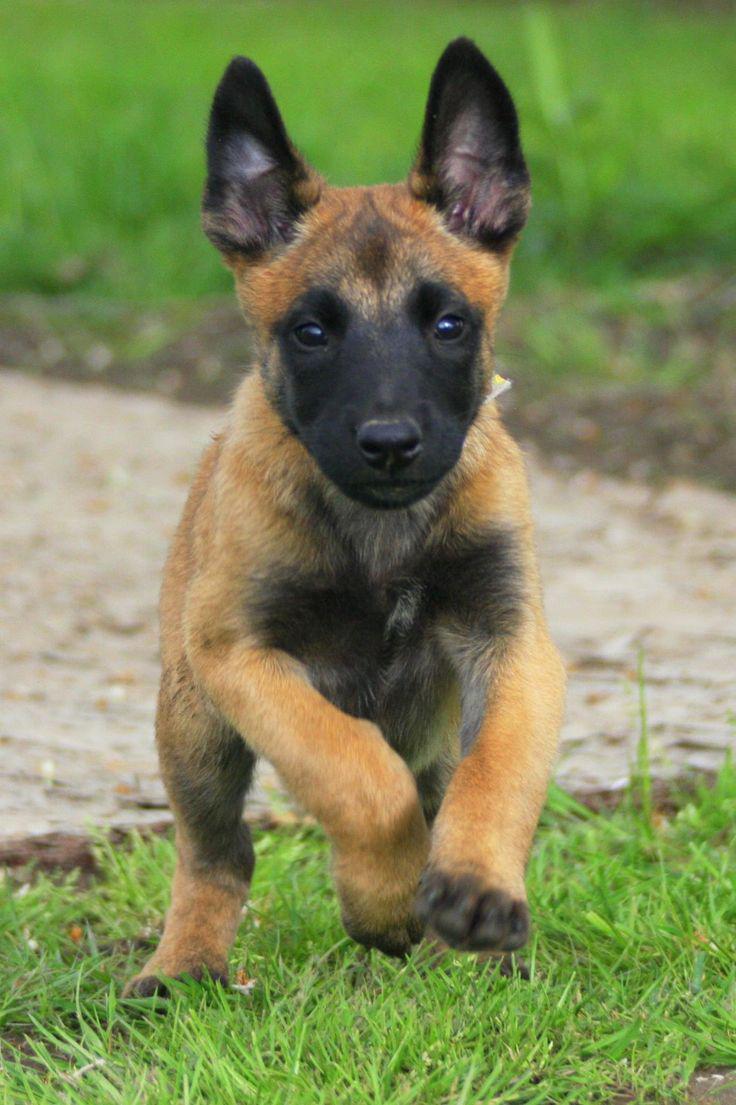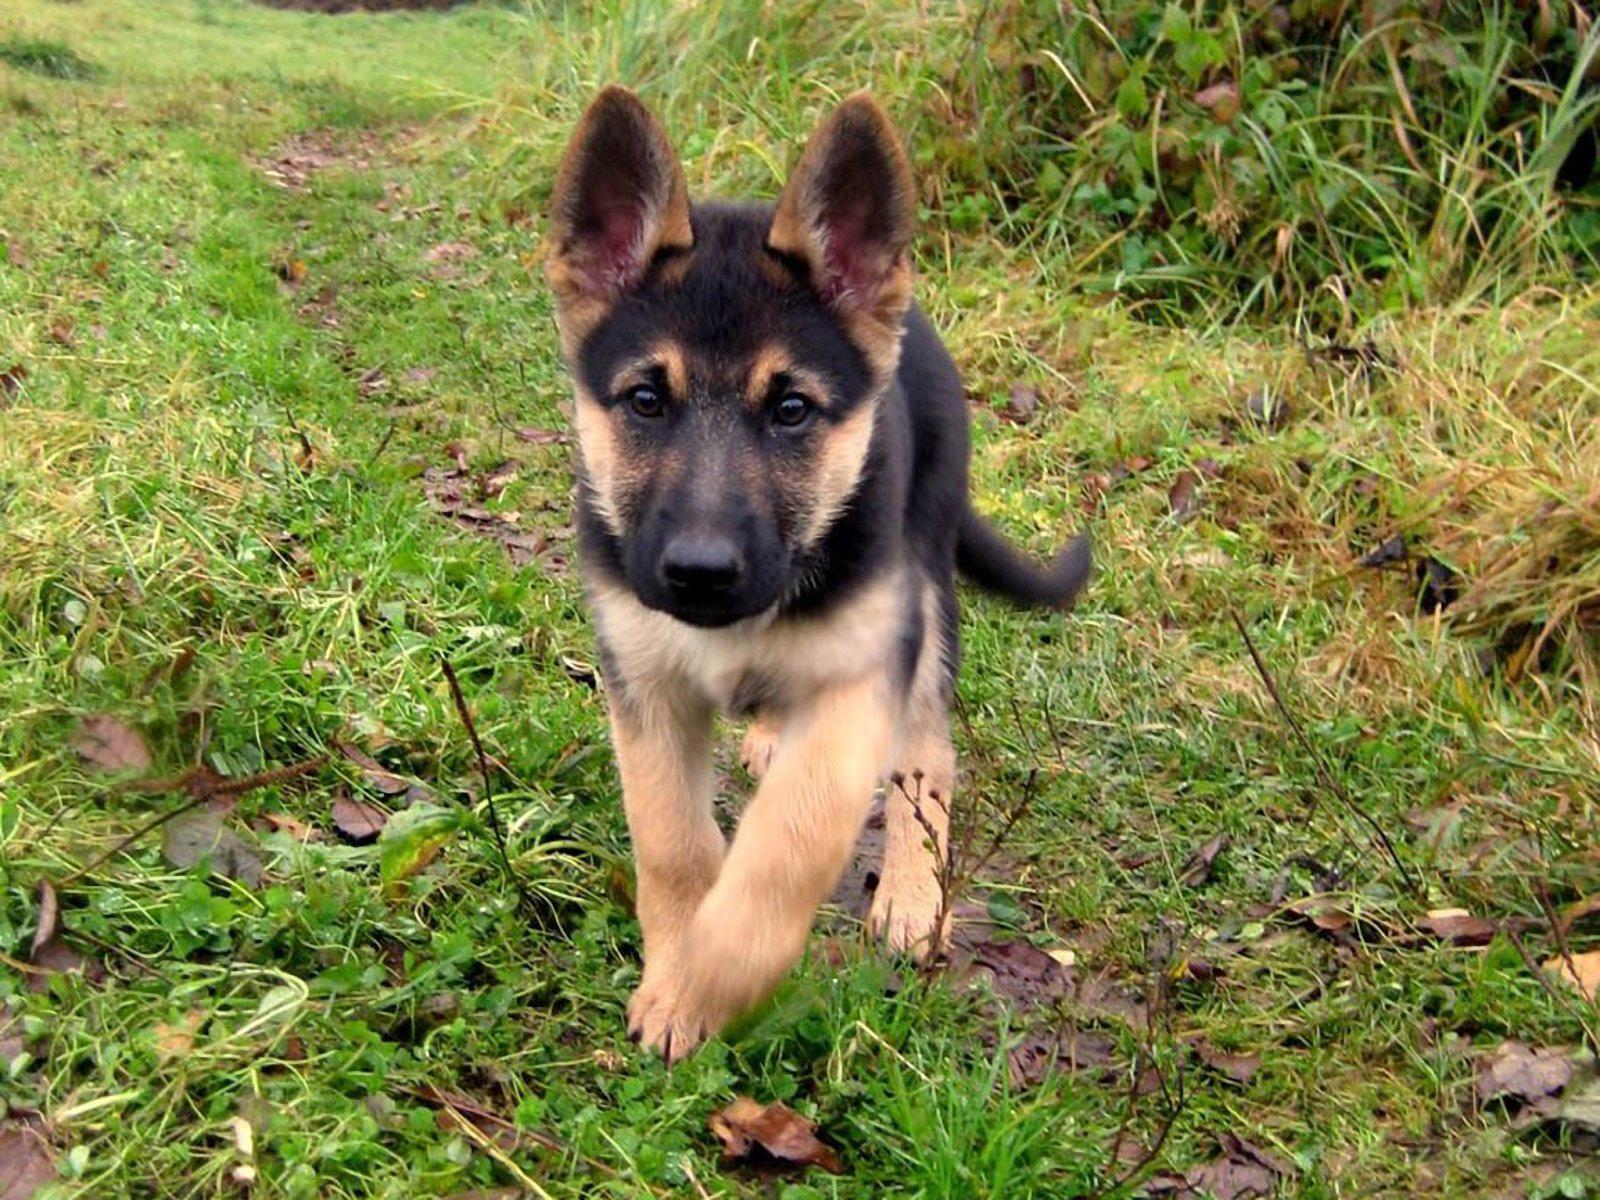The first image is the image on the left, the second image is the image on the right. Assess this claim about the two images: "One of the dogs is on a leash.". Correct or not? Answer yes or no. No. 